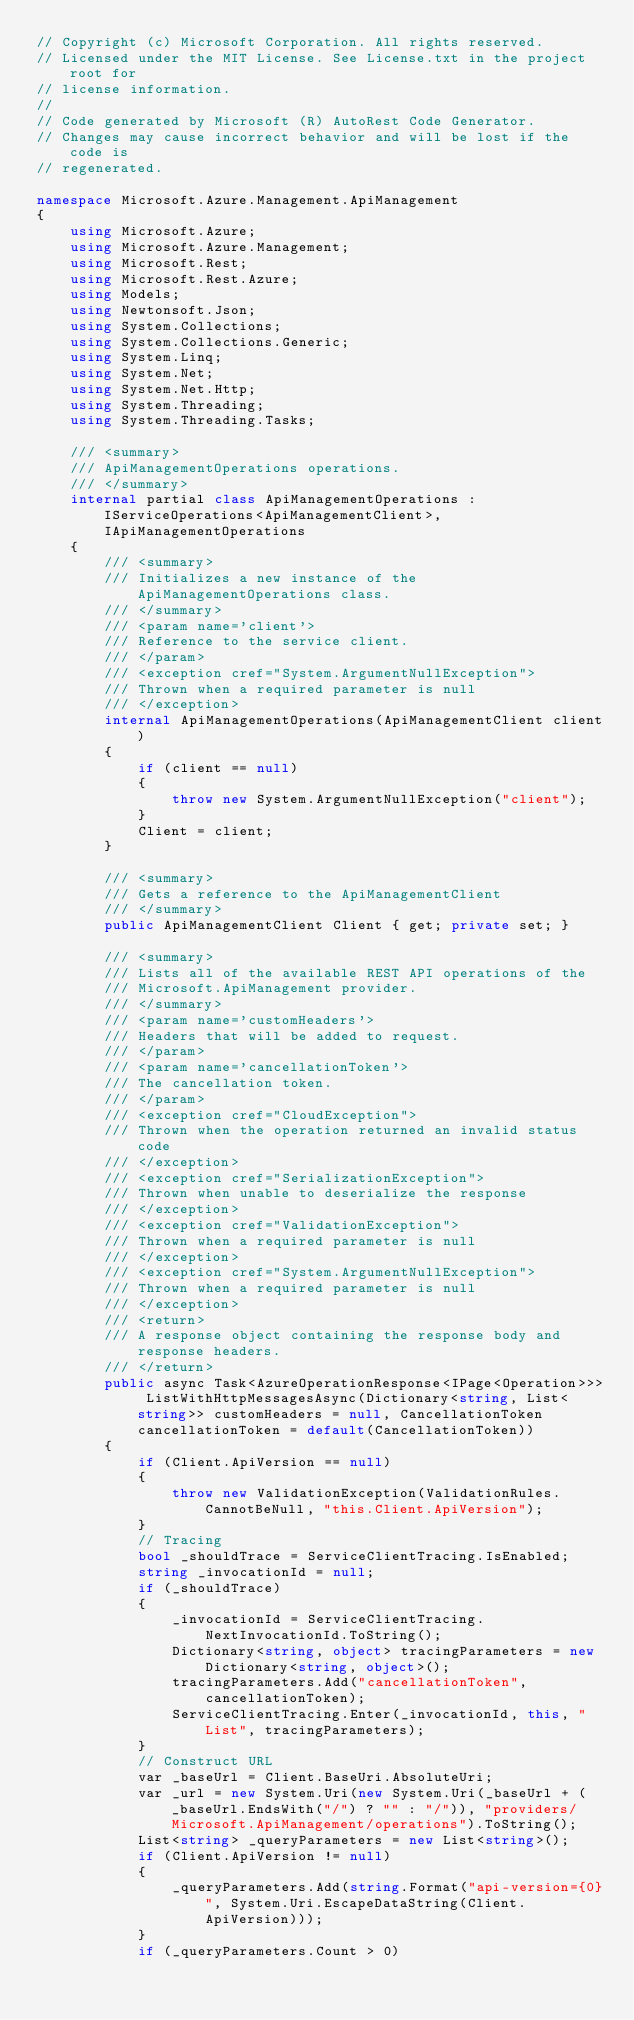Convert code to text. <code><loc_0><loc_0><loc_500><loc_500><_C#_>// Copyright (c) Microsoft Corporation. All rights reserved.
// Licensed under the MIT License. See License.txt in the project root for
// license information.
//
// Code generated by Microsoft (R) AutoRest Code Generator.
// Changes may cause incorrect behavior and will be lost if the code is
// regenerated.

namespace Microsoft.Azure.Management.ApiManagement
{
    using Microsoft.Azure;
    using Microsoft.Azure.Management;
    using Microsoft.Rest;
    using Microsoft.Rest.Azure;
    using Models;
    using Newtonsoft.Json;
    using System.Collections;
    using System.Collections.Generic;
    using System.Linq;
    using System.Net;
    using System.Net.Http;
    using System.Threading;
    using System.Threading.Tasks;

    /// <summary>
    /// ApiManagementOperations operations.
    /// </summary>
    internal partial class ApiManagementOperations : IServiceOperations<ApiManagementClient>, IApiManagementOperations
    {
        /// <summary>
        /// Initializes a new instance of the ApiManagementOperations class.
        /// </summary>
        /// <param name='client'>
        /// Reference to the service client.
        /// </param>
        /// <exception cref="System.ArgumentNullException">
        /// Thrown when a required parameter is null
        /// </exception>
        internal ApiManagementOperations(ApiManagementClient client)
        {
            if (client == null)
            {
                throw new System.ArgumentNullException("client");
            }
            Client = client;
        }

        /// <summary>
        /// Gets a reference to the ApiManagementClient
        /// </summary>
        public ApiManagementClient Client { get; private set; }

        /// <summary>
        /// Lists all of the available REST API operations of the
        /// Microsoft.ApiManagement provider.
        /// </summary>
        /// <param name='customHeaders'>
        /// Headers that will be added to request.
        /// </param>
        /// <param name='cancellationToken'>
        /// The cancellation token.
        /// </param>
        /// <exception cref="CloudException">
        /// Thrown when the operation returned an invalid status code
        /// </exception>
        /// <exception cref="SerializationException">
        /// Thrown when unable to deserialize the response
        /// </exception>
        /// <exception cref="ValidationException">
        /// Thrown when a required parameter is null
        /// </exception>
        /// <exception cref="System.ArgumentNullException">
        /// Thrown when a required parameter is null
        /// </exception>
        /// <return>
        /// A response object containing the response body and response headers.
        /// </return>
        public async Task<AzureOperationResponse<IPage<Operation>>> ListWithHttpMessagesAsync(Dictionary<string, List<string>> customHeaders = null, CancellationToken cancellationToken = default(CancellationToken))
        {
            if (Client.ApiVersion == null)
            {
                throw new ValidationException(ValidationRules.CannotBeNull, "this.Client.ApiVersion");
            }
            // Tracing
            bool _shouldTrace = ServiceClientTracing.IsEnabled;
            string _invocationId = null;
            if (_shouldTrace)
            {
                _invocationId = ServiceClientTracing.NextInvocationId.ToString();
                Dictionary<string, object> tracingParameters = new Dictionary<string, object>();
                tracingParameters.Add("cancellationToken", cancellationToken);
                ServiceClientTracing.Enter(_invocationId, this, "List", tracingParameters);
            }
            // Construct URL
            var _baseUrl = Client.BaseUri.AbsoluteUri;
            var _url = new System.Uri(new System.Uri(_baseUrl + (_baseUrl.EndsWith("/") ? "" : "/")), "providers/Microsoft.ApiManagement/operations").ToString();
            List<string> _queryParameters = new List<string>();
            if (Client.ApiVersion != null)
            {
                _queryParameters.Add(string.Format("api-version={0}", System.Uri.EscapeDataString(Client.ApiVersion)));
            }
            if (_queryParameters.Count > 0)</code> 